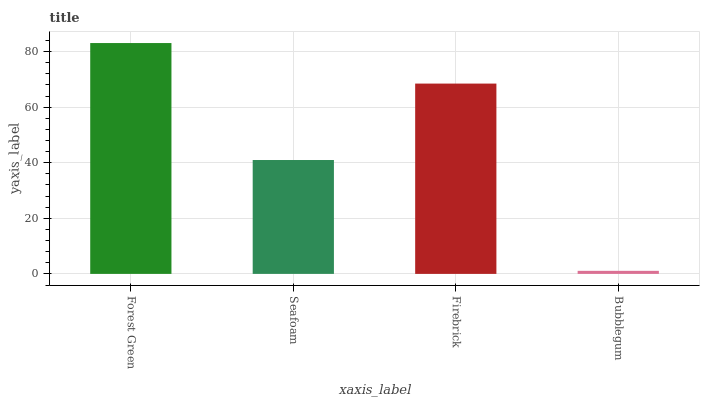Is Seafoam the minimum?
Answer yes or no. No. Is Seafoam the maximum?
Answer yes or no. No. Is Forest Green greater than Seafoam?
Answer yes or no. Yes. Is Seafoam less than Forest Green?
Answer yes or no. Yes. Is Seafoam greater than Forest Green?
Answer yes or no. No. Is Forest Green less than Seafoam?
Answer yes or no. No. Is Firebrick the high median?
Answer yes or no. Yes. Is Seafoam the low median?
Answer yes or no. Yes. Is Seafoam the high median?
Answer yes or no. No. Is Bubblegum the low median?
Answer yes or no. No. 